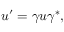<formula> <loc_0><loc_0><loc_500><loc_500>u ^ { \prime } = \gamma u \gamma ^ { * } ,</formula> 